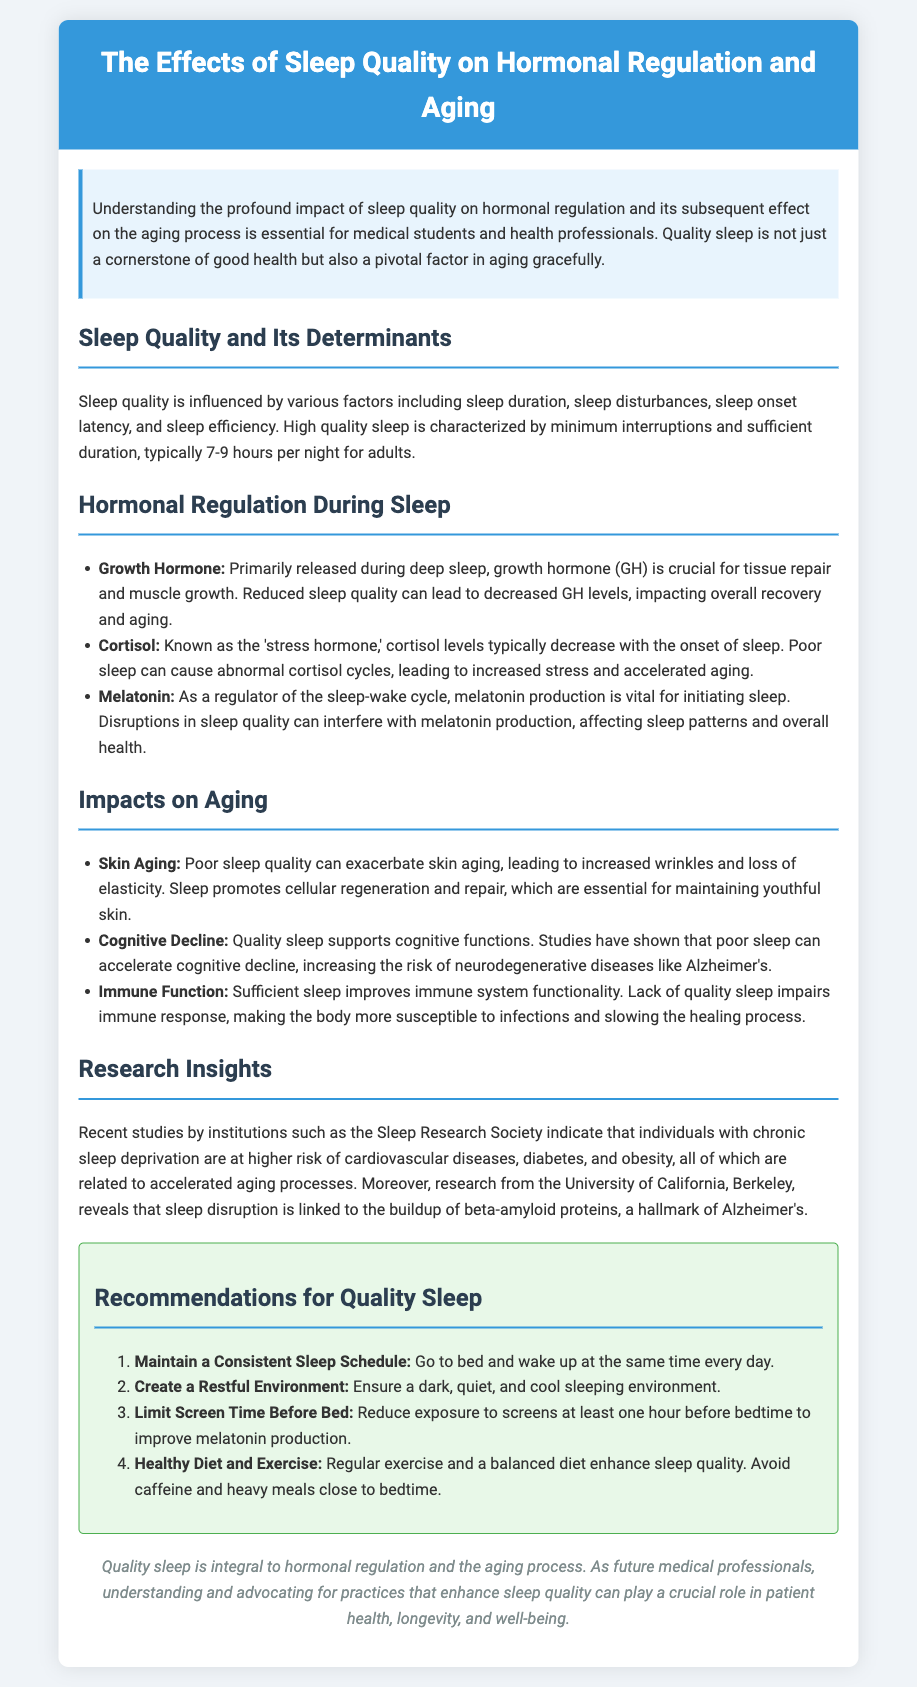What is the optimal sleep duration for adults? The document states that high quality sleep is typically 7-9 hours per night for adults.
Answer: 7-9 hours Which hormone is primarily released during deep sleep? The document identifies growth hormone (GH) as primarily released during deep sleep.
Answer: Growth Hormone What impact does poor sleep have on skin aging? The document notes that poor sleep quality can exacerbate skin aging, leading to increased wrinkles and loss of elasticity.
Answer: Increased wrinkles What is one recommendation for improving sleep quality? The document provides several recommendations, one of which is to create a restful environment.
Answer: Create a restful environment What notable positive effect does sufficient sleep have on the immune system? According to the document, sufficient sleep improves immune system functionality.
Answer: Improves functionality How does chronic sleep deprivation relate to cardiovascular diseases? The document mentions that individuals with chronic sleep deprivation are at higher risk of cardiovascular diseases, related to accelerated aging processes.
Answer: Higher risk Which hormone's production is affected by disruptions in sleep quality? Melatonin production is affected by disruptions in sleep quality, according to the document.
Answer: Melatonin What cognitive issue is associated with poor sleep quality? The document states that poor sleep can accelerate cognitive decline, increasing the risk of neurodegenerative diseases.
Answer: Cognitive decline Who conducted recent studies on sleep deprivation and disease risk? The document attributes recent studies to institutions such as the Sleep Research Society.
Answer: Sleep Research Society 